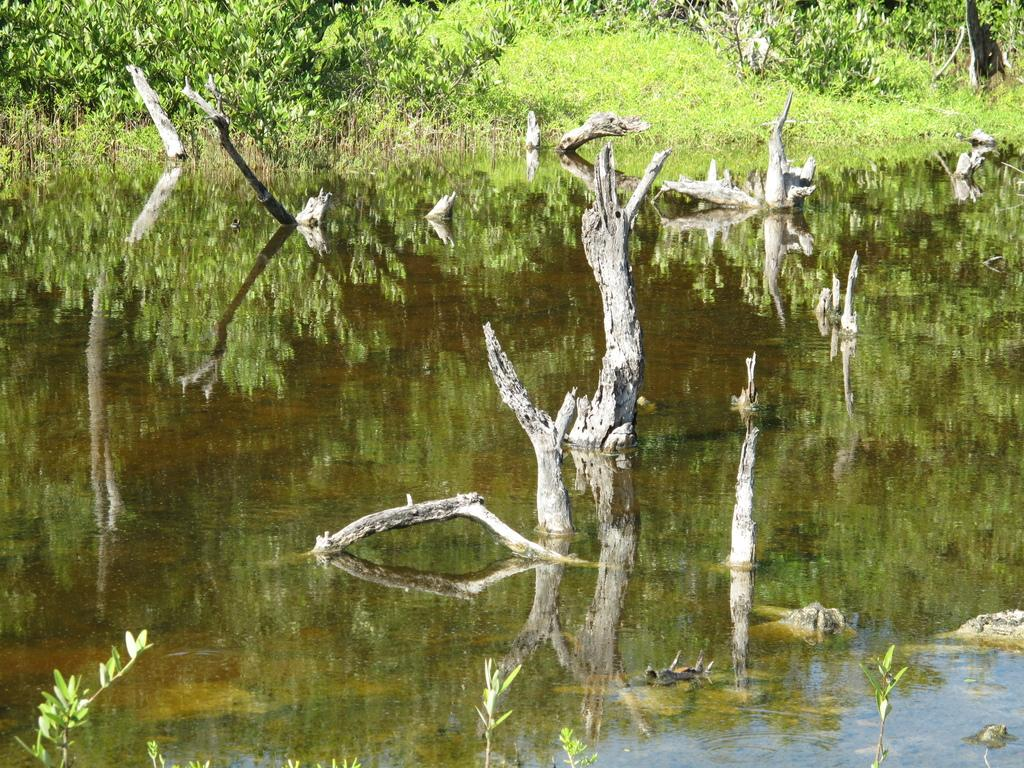What is happening in the image? There is water flowing in the image. What can be seen in the water? Tree trunks are visible in the water. What type of vegetation is present in the image? There are trees with branches and leaves in the image. What type of fire can be seen burning in the image? There is no fire present in the image; it features water flowing with tree trunks and trees with branches and leaves. How many eggs are visible in the image? There are no eggs present in the image. 